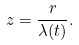<formula> <loc_0><loc_0><loc_500><loc_500>z = \frac { r } { \lambda ( t ) } .</formula> 